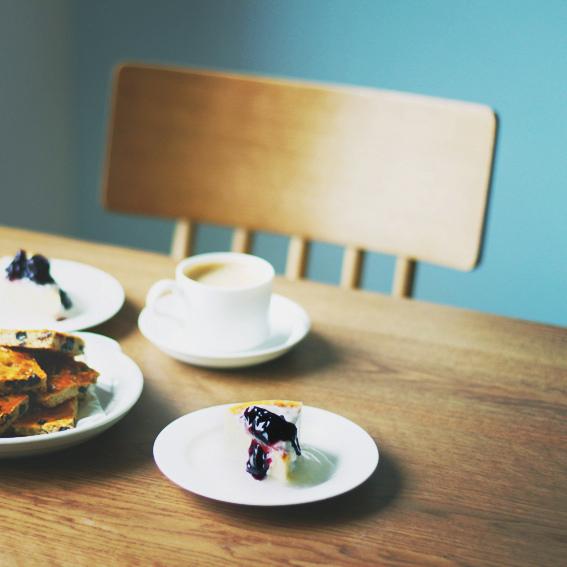Is there cream in the coffee?
Give a very brief answer. Yes. Is there anyone in the chair?
Keep it brief. No. What color are the dishes?
Short answer required. White. 